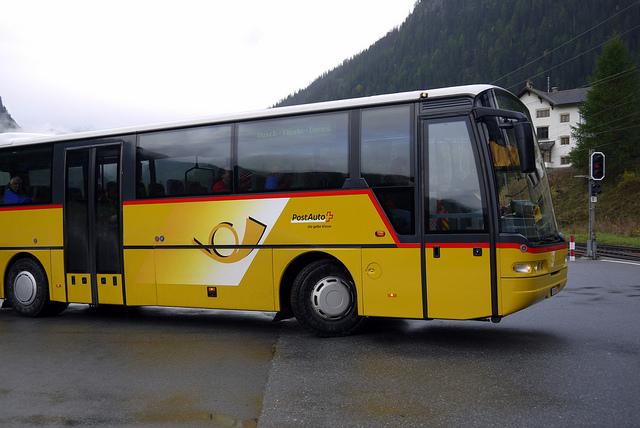What type of bus is shown?
Concise answer only. Tour. What color is the bus?
Give a very brief answer. Yellow. Is the vehicle turning?
Write a very short answer. Yes. How many of the bus's doors can be seen in this photo?
Short answer required. 2. 